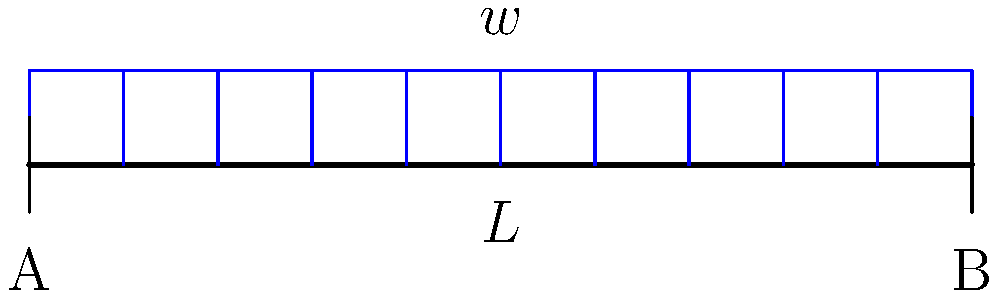Hey there, fellow night owl! Imagine we're setting up a temporary bridge for a killer outdoor festival. The bridge is 10 meters long and needs to support a distributed load of 2 kN/m. What's the maximum deflection at the center of this simply supported bridge? Assume $EI = 2 \times 10^4$ kN-m². Let's mix this up like a perfect cocktail! Alright, let's break this down step by step, just like crafting a complex drink:

1) For a simply supported beam with a uniformly distributed load, the maximum deflection occurs at the center and is given by the formula:

   $$\delta_{max} = \frac{5wL^4}{384EI}$$

   Where:
   $\delta_{max}$ = maximum deflection
   $w$ = distributed load
   $L$ = length of the beam
   $EI$ = flexural rigidity

2) We're given:
   $w = 2$ kN/m
   $L = 10$ m
   $EI = 2 \times 10^4$ kN-m²

3) Let's pour these ingredients into our formula:

   $$\delta_{max} = \frac{5 \times 2 \times 10^4}{384 \times 2 \times 10^4}$$

4) Simplify:
   $$\delta_{max} = \frac{10000}{768000}$$

5) Calculate:
   $$\delta_{max} = 0.013020833$$

6) Round to 3 decimal places:
   $$\delta_{max} \approx 0.013 \text{ m}$$

And there you have it! The maximum deflection is about 13 mm, or just over a centimeter. Not bad for a party bridge!
Answer: 0.013 m 